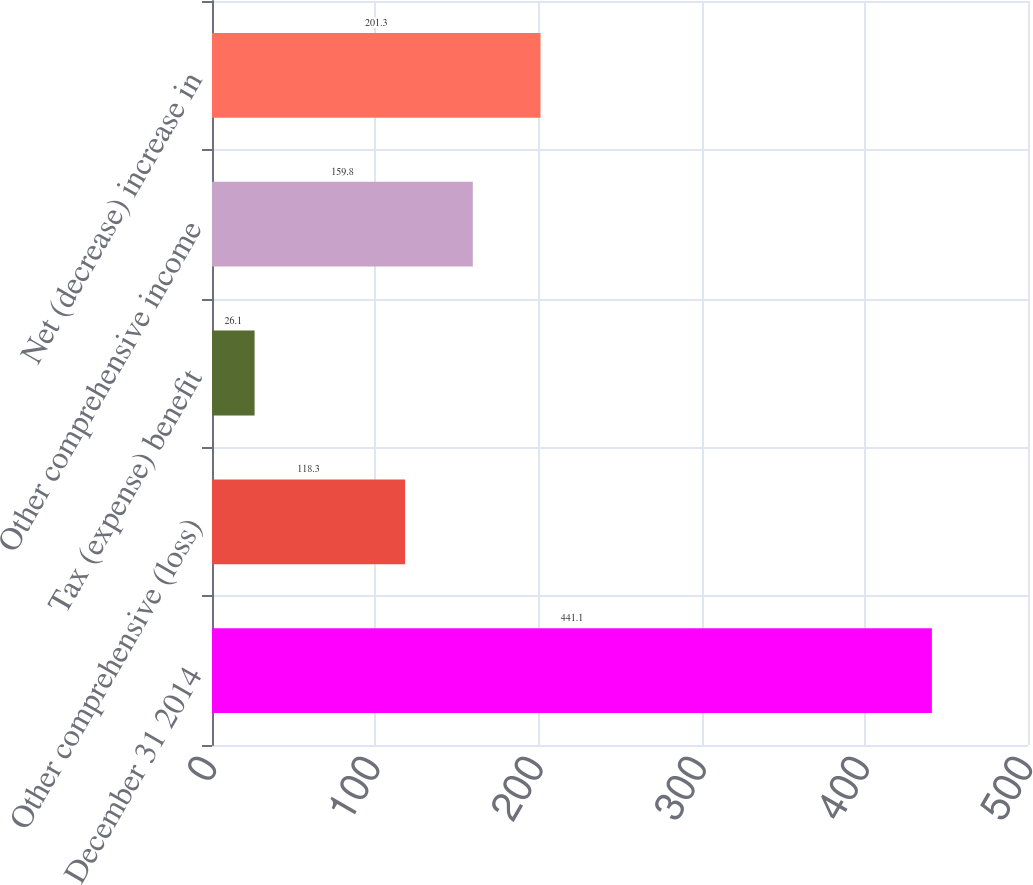<chart> <loc_0><loc_0><loc_500><loc_500><bar_chart><fcel>December 31 2014<fcel>Other comprehensive (loss)<fcel>Tax (expense) benefit<fcel>Other comprehensive income<fcel>Net (decrease) increase in<nl><fcel>441.1<fcel>118.3<fcel>26.1<fcel>159.8<fcel>201.3<nl></chart> 